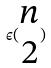<formula> <loc_0><loc_0><loc_500><loc_500>\epsilon ( \begin{matrix} n \\ 2 \end{matrix} )</formula> 